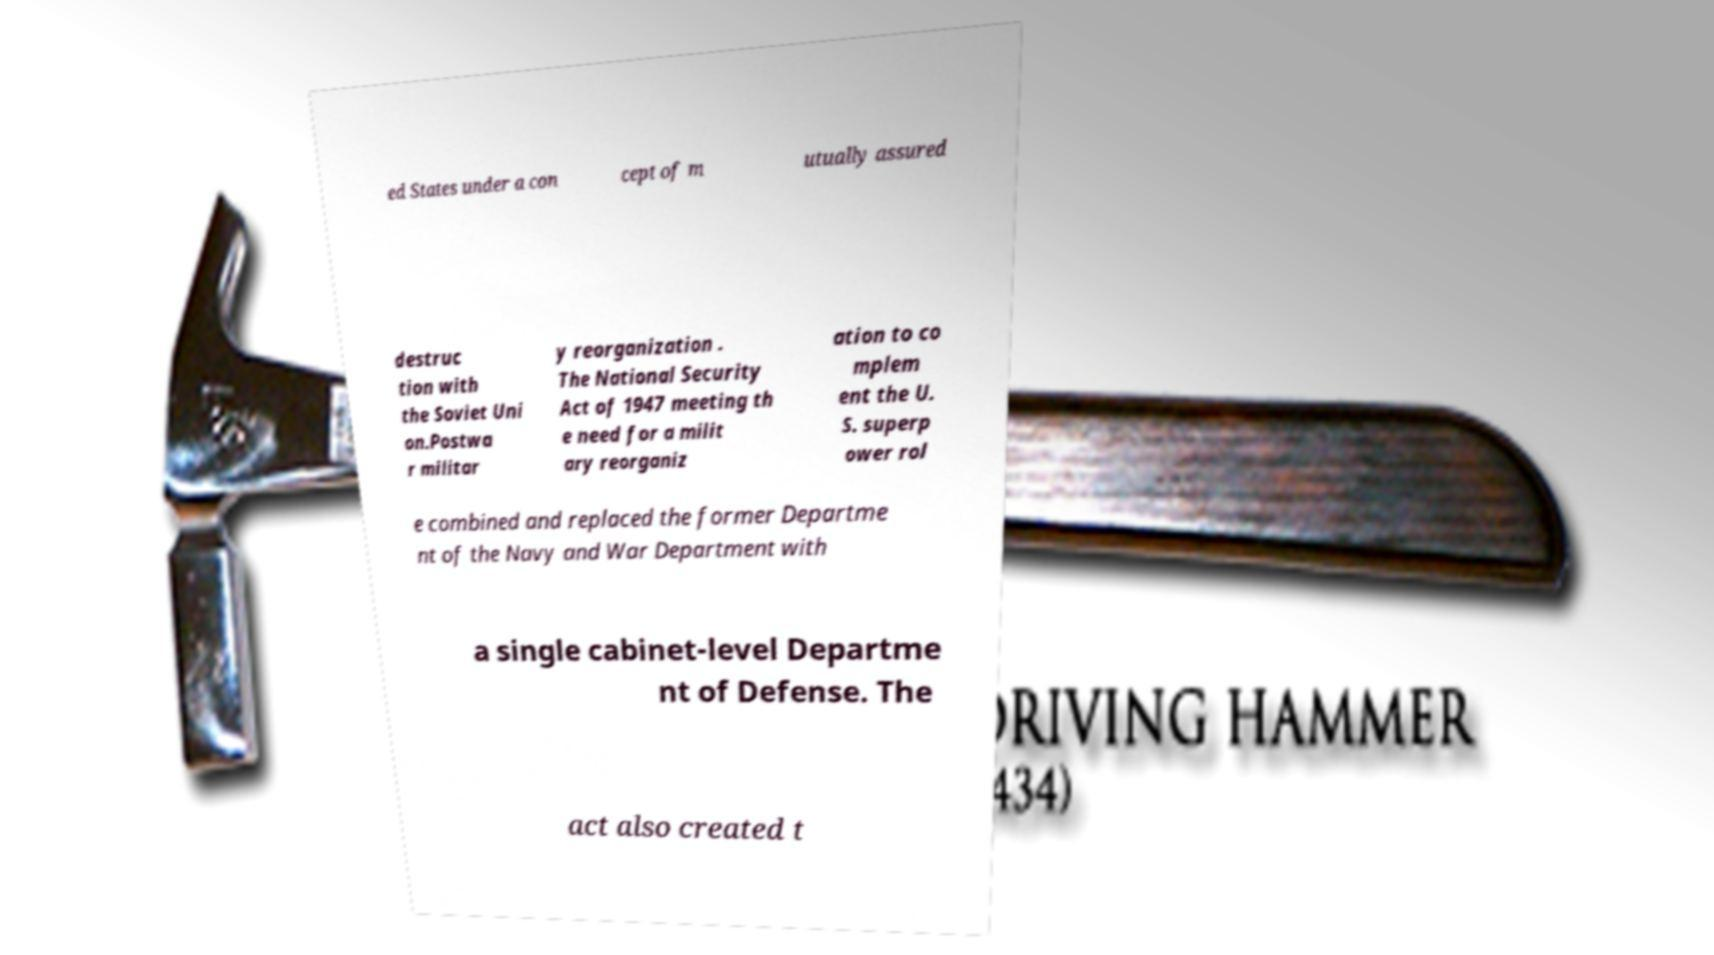What messages or text are displayed in this image? I need them in a readable, typed format. ed States under a con cept of m utually assured destruc tion with the Soviet Uni on.Postwa r militar y reorganization . The National Security Act of 1947 meeting th e need for a milit ary reorganiz ation to co mplem ent the U. S. superp ower rol e combined and replaced the former Departme nt of the Navy and War Department with a single cabinet-level Departme nt of Defense. The act also created t 